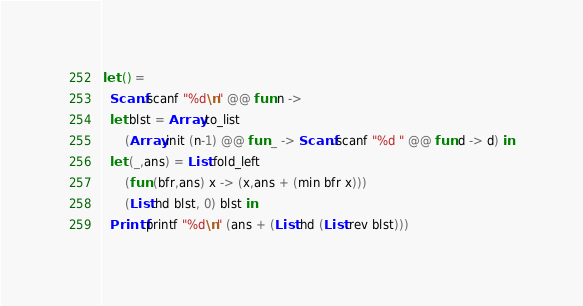<code> <loc_0><loc_0><loc_500><loc_500><_OCaml_>let () =
  Scanf.scanf "%d\n" @@ fun n ->
  let blst = Array.to_list
      (Array.init (n-1) @@ fun _ -> Scanf.scanf "%d " @@ fun d -> d) in
  let (_,ans) = List.fold_left
      (fun (bfr,ans) x -> (x,ans + (min bfr x)))
      (List.hd blst, 0) blst in
  Printf.printf "%d\n" (ans + (List.hd (List.rev blst)))</code> 